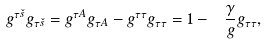Convert formula to latex. <formula><loc_0><loc_0><loc_500><loc_500>g ^ { \tau \check { s } } g _ { \tau \check { s } } = g ^ { \tau A } g _ { \tau A } - g ^ { \tau \tau } g _ { \tau \tau } = 1 - { \ \frac { \gamma } { g } } g _ { \tau \tau } ,</formula> 